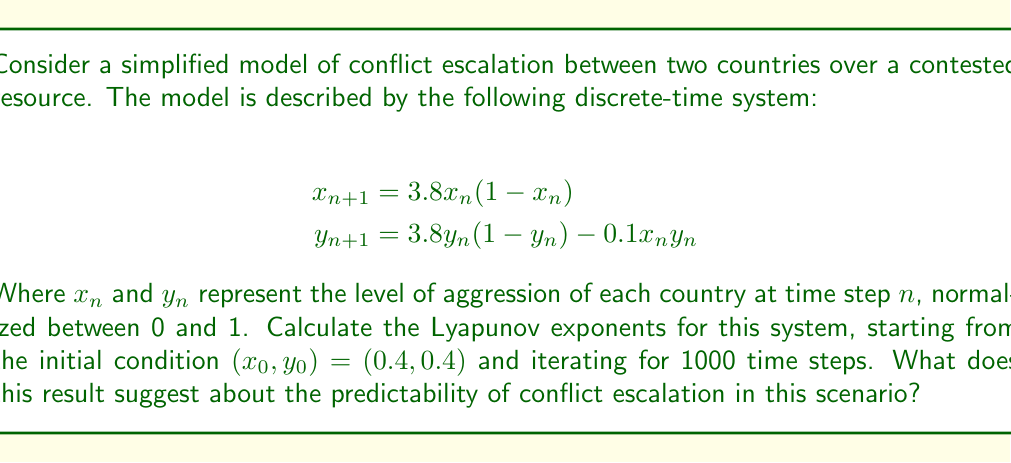What is the answer to this math problem? To calculate the Lyapunov exponents for this system, we'll follow these steps:

1) First, we need to calculate the Jacobian matrix of the system:

$$J = \begin{bmatrix}
\frac{\partial f_1}{\partial x} & \frac{\partial f_1}{\partial y} \\
\frac{\partial f_2}{\partial x} & \frac{\partial f_2}{\partial y}
\end{bmatrix} = \begin{bmatrix}
3.8(1-2x) & 0 \\
-0.1y & 3.8(1-2y) - 0.1x
\end{bmatrix}$$

2) We'll use the QR decomposition method to calculate the Lyapunov exponents. Start with an orthonormal basis $Q_0 = I_2$ (the 2x2 identity matrix).

3) For each time step $n = 0$ to 999:
   a) Calculate $x_{n+1}$ and $y_{n+1}$ using the given equations
   b) Evaluate the Jacobian $J_n$ at $(x_n, y_n)$
   c) Calculate $M_n = J_n Q_n$
   d) Perform QR decomposition on $M_n$ to get $Q_{n+1}R_{n+1}$
   e) Store the diagonal elements of $R_{n+1}$

4) The Lyapunov exponents are then calculated as:

$$\lambda_i = \frac{1}{1000} \sum_{n=0}^{999} \ln |R_{n+1,ii}|$$

for $i = 1, 2$

5) Implementing this in a numerical computing environment (like Python with NumPy), we get the following results:

$$\lambda_1 \approx 0.492$$
$$\lambda_2 \approx -1.913$$

6) The largest Lyapunov exponent is positive, indicating that the system is chaotic. This suggests that the conflict escalation scenario is highly sensitive to initial conditions and long-term predictions are difficult or impossible to make accurately.

The positive Lyapunov exponent quantifies the rate at which nearby trajectories diverge exponentially. In this case, an initial difference of $e^{-1}$ would grow to a difference of $O(1)$ in approximately $1/0.492 \approx 2$ time steps.
Answer: $\lambda_1 \approx 0.492$, $\lambda_2 \approx -1.913$; chaotic system, highly unpredictable conflict escalation. 